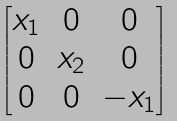Convert formula to latex. <formula><loc_0><loc_0><loc_500><loc_500>\begin{bmatrix} x _ { 1 } & 0 & 0 \\ 0 & x _ { 2 } & 0 \\ 0 & 0 & - x _ { 1 } \end{bmatrix}</formula> 